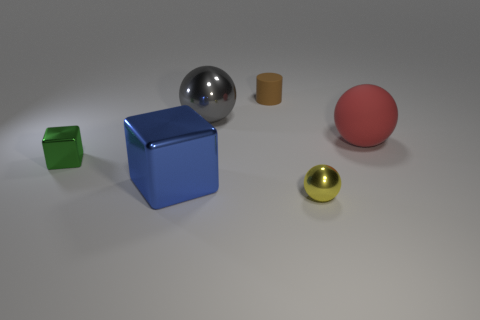There is a blue metal thing; are there any big gray balls in front of it?
Provide a short and direct response. No. Does the gray metal object have the same shape as the small shiny object right of the green metal cube?
Your answer should be very brief. Yes. What number of things are shiny objects that are to the right of the small green metal cube or large gray shiny balls?
Give a very brief answer. 3. Is there anything else that has the same material as the gray thing?
Your response must be concise. Yes. What number of objects are both in front of the brown matte cylinder and to the left of the tiny sphere?
Your answer should be very brief. 3. What number of objects are either things right of the small yellow sphere or shiny objects right of the big blue metallic cube?
Keep it short and to the point. 3. How many other objects are there of the same shape as the red rubber thing?
Offer a very short reply. 2. How many other objects are there of the same size as the rubber cylinder?
Give a very brief answer. 2. Does the large red sphere have the same material as the tiny cylinder?
Provide a short and direct response. Yes. There is a ball to the left of the metallic sphere on the right side of the brown matte cylinder; what color is it?
Make the answer very short. Gray. 